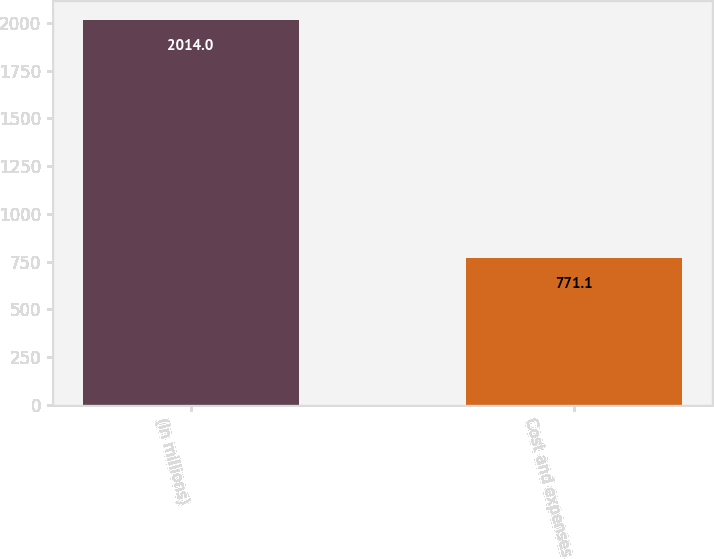Convert chart. <chart><loc_0><loc_0><loc_500><loc_500><bar_chart><fcel>(In millions)<fcel>Cost and expenses<nl><fcel>2014<fcel>771.1<nl></chart> 